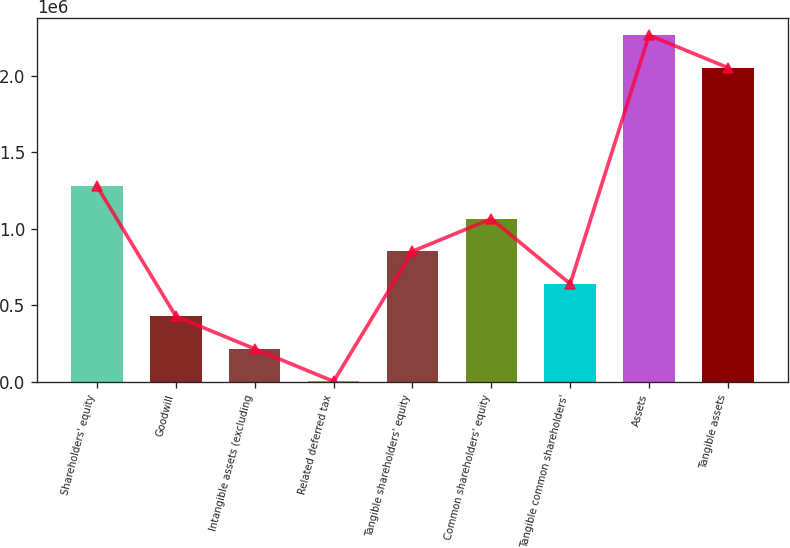Convert chart. <chart><loc_0><loc_0><loc_500><loc_500><bar_chart><fcel>Shareholders' equity<fcel>Goodwill<fcel>Intangible assets (excluding<fcel>Related deferred tax<fcel>Tangible shareholders' equity<fcel>Common shareholders' equity<fcel>Tangible common shareholders'<fcel>Assets<fcel>Tangible assets<nl><fcel>1.27854e+06<fcel>428029<fcel>215402<fcel>2775<fcel>853283<fcel>1.06591e+06<fcel>640656<fcel>2.26639e+06<fcel>2.05376e+06<nl></chart> 